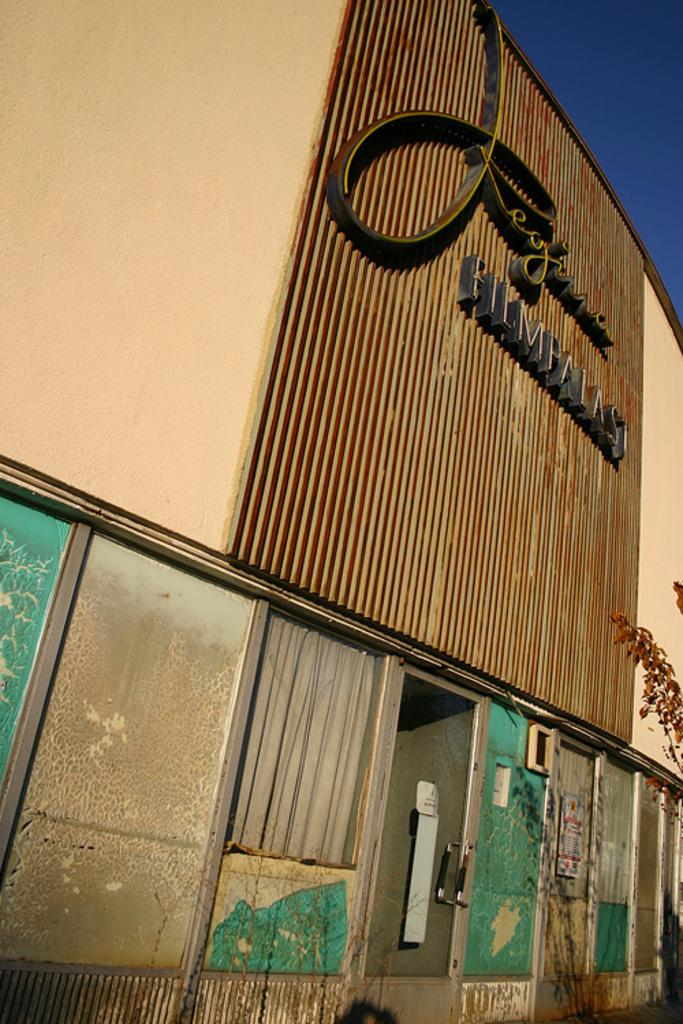What is the main subject of the image? The main subject of the image is a building. Can you identify any specific features of the building? Yes, the building has windows. What else can be seen on the right side of the image? There is a branch of a tree on the right side of the image. What is visible in the right top corner of the image? The sky is visible in the right top corner of the image. What type of caption is written on the building in the image? There is no caption written on the building in the image; it only has a name. Can you describe the waves in the image? There are no waves present in the image. 